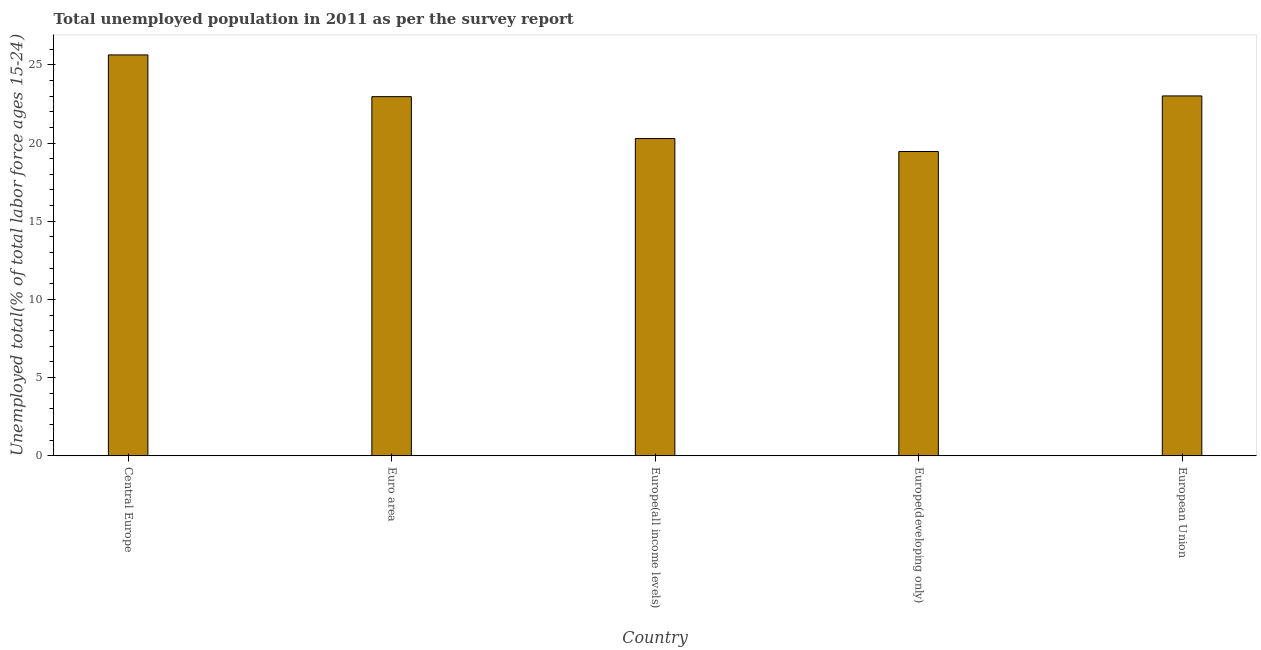Does the graph contain grids?
Keep it short and to the point. No. What is the title of the graph?
Make the answer very short. Total unemployed population in 2011 as per the survey report. What is the label or title of the Y-axis?
Keep it short and to the point. Unemployed total(% of total labor force ages 15-24). What is the unemployed youth in Europe(all income levels)?
Your response must be concise. 20.29. Across all countries, what is the maximum unemployed youth?
Give a very brief answer. 25.64. Across all countries, what is the minimum unemployed youth?
Offer a very short reply. 19.46. In which country was the unemployed youth maximum?
Offer a terse response. Central Europe. In which country was the unemployed youth minimum?
Offer a terse response. Europe(developing only). What is the sum of the unemployed youth?
Provide a short and direct response. 111.38. What is the difference between the unemployed youth in Central Europe and Europe(all income levels)?
Keep it short and to the point. 5.35. What is the average unemployed youth per country?
Provide a short and direct response. 22.27. What is the median unemployed youth?
Your answer should be very brief. 22.97. What is the ratio of the unemployed youth in Europe(all income levels) to that in European Union?
Offer a terse response. 0.88. What is the difference between the highest and the second highest unemployed youth?
Keep it short and to the point. 2.62. What is the difference between the highest and the lowest unemployed youth?
Provide a succinct answer. 6.18. How many bars are there?
Give a very brief answer. 5. How many countries are there in the graph?
Give a very brief answer. 5. What is the difference between two consecutive major ticks on the Y-axis?
Make the answer very short. 5. Are the values on the major ticks of Y-axis written in scientific E-notation?
Make the answer very short. No. What is the Unemployed total(% of total labor force ages 15-24) in Central Europe?
Provide a short and direct response. 25.64. What is the Unemployed total(% of total labor force ages 15-24) in Euro area?
Ensure brevity in your answer.  22.97. What is the Unemployed total(% of total labor force ages 15-24) in Europe(all income levels)?
Your answer should be very brief. 20.29. What is the Unemployed total(% of total labor force ages 15-24) of Europe(developing only)?
Your answer should be very brief. 19.46. What is the Unemployed total(% of total labor force ages 15-24) in European Union?
Offer a very short reply. 23.02. What is the difference between the Unemployed total(% of total labor force ages 15-24) in Central Europe and Euro area?
Give a very brief answer. 2.67. What is the difference between the Unemployed total(% of total labor force ages 15-24) in Central Europe and Europe(all income levels)?
Keep it short and to the point. 5.35. What is the difference between the Unemployed total(% of total labor force ages 15-24) in Central Europe and Europe(developing only)?
Offer a terse response. 6.18. What is the difference between the Unemployed total(% of total labor force ages 15-24) in Central Europe and European Union?
Give a very brief answer. 2.62. What is the difference between the Unemployed total(% of total labor force ages 15-24) in Euro area and Europe(all income levels)?
Offer a terse response. 2.68. What is the difference between the Unemployed total(% of total labor force ages 15-24) in Euro area and Europe(developing only)?
Offer a very short reply. 3.51. What is the difference between the Unemployed total(% of total labor force ages 15-24) in Euro area and European Union?
Give a very brief answer. -0.05. What is the difference between the Unemployed total(% of total labor force ages 15-24) in Europe(all income levels) and Europe(developing only)?
Make the answer very short. 0.83. What is the difference between the Unemployed total(% of total labor force ages 15-24) in Europe(all income levels) and European Union?
Your answer should be very brief. -2.73. What is the difference between the Unemployed total(% of total labor force ages 15-24) in Europe(developing only) and European Union?
Your answer should be compact. -3.56. What is the ratio of the Unemployed total(% of total labor force ages 15-24) in Central Europe to that in Euro area?
Your response must be concise. 1.12. What is the ratio of the Unemployed total(% of total labor force ages 15-24) in Central Europe to that in Europe(all income levels)?
Keep it short and to the point. 1.26. What is the ratio of the Unemployed total(% of total labor force ages 15-24) in Central Europe to that in Europe(developing only)?
Offer a terse response. 1.32. What is the ratio of the Unemployed total(% of total labor force ages 15-24) in Central Europe to that in European Union?
Your answer should be very brief. 1.11. What is the ratio of the Unemployed total(% of total labor force ages 15-24) in Euro area to that in Europe(all income levels)?
Make the answer very short. 1.13. What is the ratio of the Unemployed total(% of total labor force ages 15-24) in Euro area to that in Europe(developing only)?
Offer a very short reply. 1.18. What is the ratio of the Unemployed total(% of total labor force ages 15-24) in Europe(all income levels) to that in Europe(developing only)?
Your response must be concise. 1.04. What is the ratio of the Unemployed total(% of total labor force ages 15-24) in Europe(all income levels) to that in European Union?
Provide a short and direct response. 0.88. What is the ratio of the Unemployed total(% of total labor force ages 15-24) in Europe(developing only) to that in European Union?
Keep it short and to the point. 0.84. 